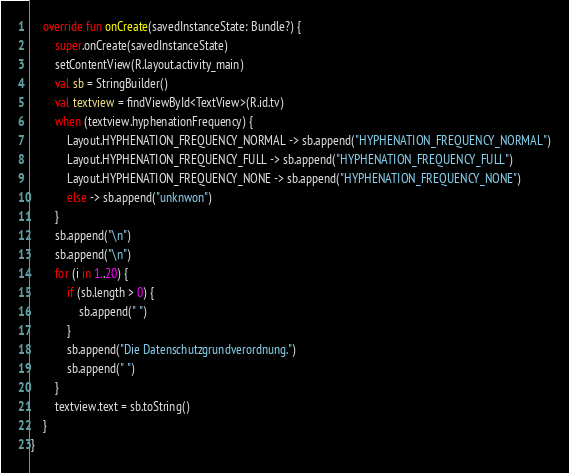<code> <loc_0><loc_0><loc_500><loc_500><_Kotlin_>    override fun onCreate(savedInstanceState: Bundle?) {
        super.onCreate(savedInstanceState)
        setContentView(R.layout.activity_main)
        val sb = StringBuilder()
        val textview = findViewById<TextView>(R.id.tv)
        when (textview.hyphenationFrequency) {
            Layout.HYPHENATION_FREQUENCY_NORMAL -> sb.append("HYPHENATION_FREQUENCY_NORMAL")
            Layout.HYPHENATION_FREQUENCY_FULL -> sb.append("HYPHENATION_FREQUENCY_FULL")
            Layout.HYPHENATION_FREQUENCY_NONE -> sb.append("HYPHENATION_FREQUENCY_NONE")
            else -> sb.append("unknwon")
        }
        sb.append("\n")
        sb.append("\n")
        for (i in 1..20) {
            if (sb.length > 0) {
                sb.append(" ")
            }
            sb.append("Die Datenschutzgrundverordnung.")
            sb.append(" ")
        }
        textview.text = sb.toString()
    }
}
</code> 